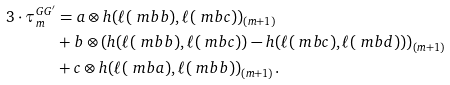<formula> <loc_0><loc_0><loc_500><loc_500>3 \cdot \tau ^ { G G ^ { \prime } } _ { m } & = a \otimes h ( \ell ( \ m b { b } ) , \ell ( \ m b { c } ) ) _ { ( m + 1 ) } \\ & + b \otimes \left ( h ( \ell ( \ m b { b } ) , \ell ( \ m b { c } ) ) - h ( \ell ( \ m b { c } ) , \ell ( \ m b { d } ) ) \right ) _ { ( m + 1 ) } \\ & + c \otimes h ( \ell ( \ m b { a } ) , \ell ( \ m b { b } ) ) _ { ( m + 1 ) } .</formula> 